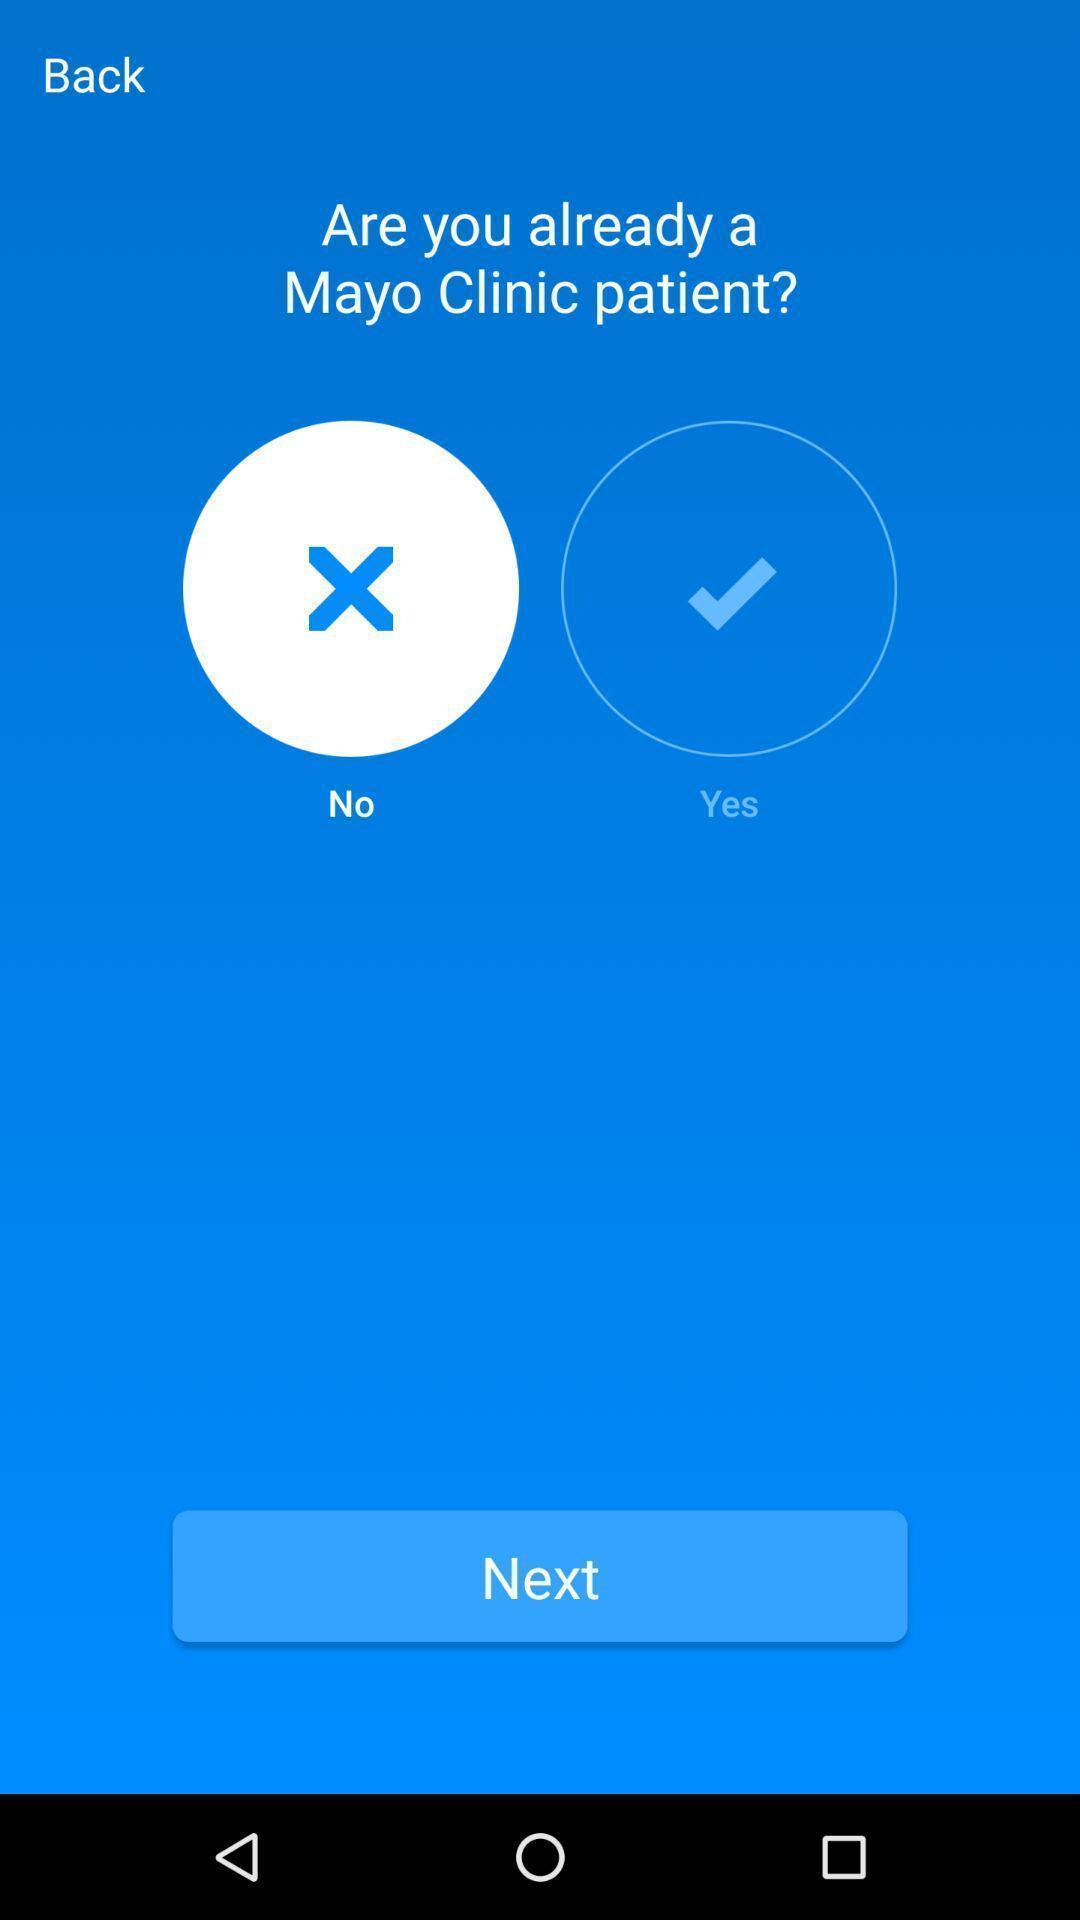Tell me about the visual elements in this screen capture. Showing confirmation page in health app. 